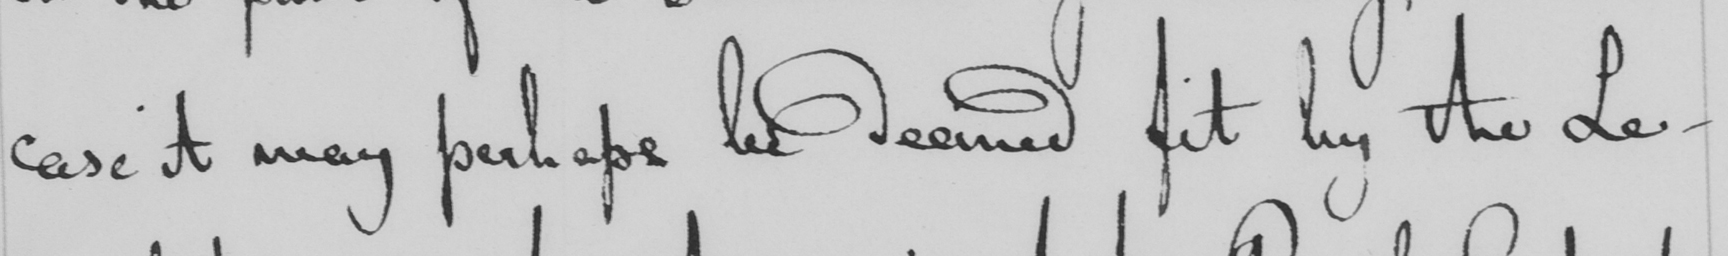What is written in this line of handwriting? case it may perhaps be deemed fit by the Le- 